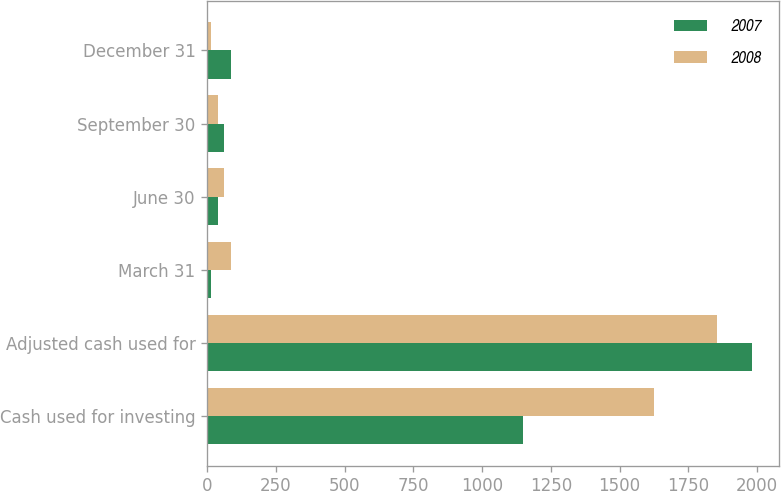<chart> <loc_0><loc_0><loc_500><loc_500><stacked_bar_chart><ecel><fcel>Cash used for investing<fcel>Adjusted cash used for<fcel>March 31<fcel>June 30<fcel>September 30<fcel>December 31<nl><fcel>2007<fcel>1150.1<fcel>1981.9<fcel>12.5<fcel>37.5<fcel>62.5<fcel>87.5<nl><fcel>2008<fcel>1624.7<fcel>1854.1<fcel>87.5<fcel>62.5<fcel>37.5<fcel>12.5<nl></chart> 